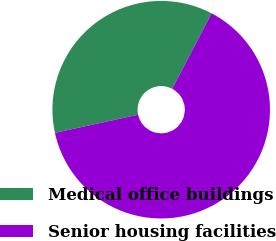Convert chart to OTSL. <chart><loc_0><loc_0><loc_500><loc_500><pie_chart><fcel>Medical office buildings<fcel>Senior housing facilities<nl><fcel>36.08%<fcel>63.92%<nl></chart> 